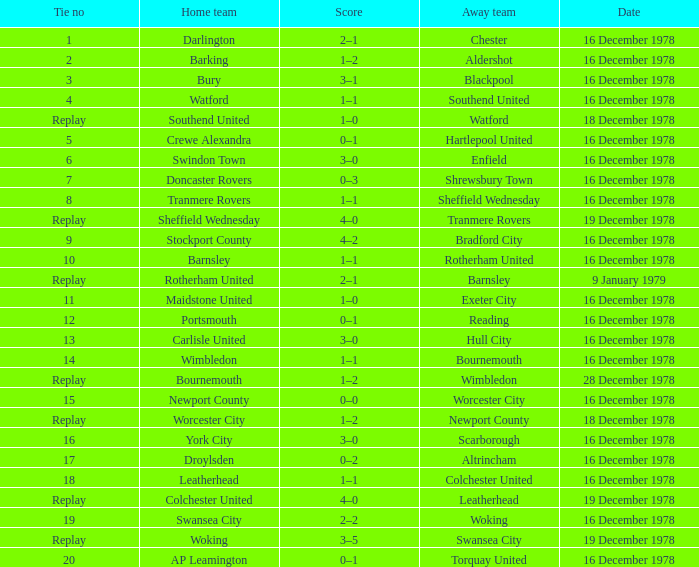What is the tie no for the home team swansea city? 19.0. Can you parse all the data within this table? {'header': ['Tie no', 'Home team', 'Score', 'Away team', 'Date'], 'rows': [['1', 'Darlington', '2–1', 'Chester', '16 December 1978'], ['2', 'Barking', '1–2', 'Aldershot', '16 December 1978'], ['3', 'Bury', '3–1', 'Blackpool', '16 December 1978'], ['4', 'Watford', '1–1', 'Southend United', '16 December 1978'], ['Replay', 'Southend United', '1–0', 'Watford', '18 December 1978'], ['5', 'Crewe Alexandra', '0–1', 'Hartlepool United', '16 December 1978'], ['6', 'Swindon Town', '3–0', 'Enfield', '16 December 1978'], ['7', 'Doncaster Rovers', '0–3', 'Shrewsbury Town', '16 December 1978'], ['8', 'Tranmere Rovers', '1–1', 'Sheffield Wednesday', '16 December 1978'], ['Replay', 'Sheffield Wednesday', '4–0', 'Tranmere Rovers', '19 December 1978'], ['9', 'Stockport County', '4–2', 'Bradford City', '16 December 1978'], ['10', 'Barnsley', '1–1', 'Rotherham United', '16 December 1978'], ['Replay', 'Rotherham United', '2–1', 'Barnsley', '9 January 1979'], ['11', 'Maidstone United', '1–0', 'Exeter City', '16 December 1978'], ['12', 'Portsmouth', '0–1', 'Reading', '16 December 1978'], ['13', 'Carlisle United', '3–0', 'Hull City', '16 December 1978'], ['14', 'Wimbledon', '1–1', 'Bournemouth', '16 December 1978'], ['Replay', 'Bournemouth', '1–2', 'Wimbledon', '28 December 1978'], ['15', 'Newport County', '0–0', 'Worcester City', '16 December 1978'], ['Replay', 'Worcester City', '1–2', 'Newport County', '18 December 1978'], ['16', 'York City', '3–0', 'Scarborough', '16 December 1978'], ['17', 'Droylsden', '0–2', 'Altrincham', '16 December 1978'], ['18', 'Leatherhead', '1–1', 'Colchester United', '16 December 1978'], ['Replay', 'Colchester United', '4–0', 'Leatherhead', '19 December 1978'], ['19', 'Swansea City', '2–2', 'Woking', '16 December 1978'], ['Replay', 'Woking', '3–5', 'Swansea City', '19 December 1978'], ['20', 'AP Leamington', '0–1', 'Torquay United', '16 December 1978']]} 